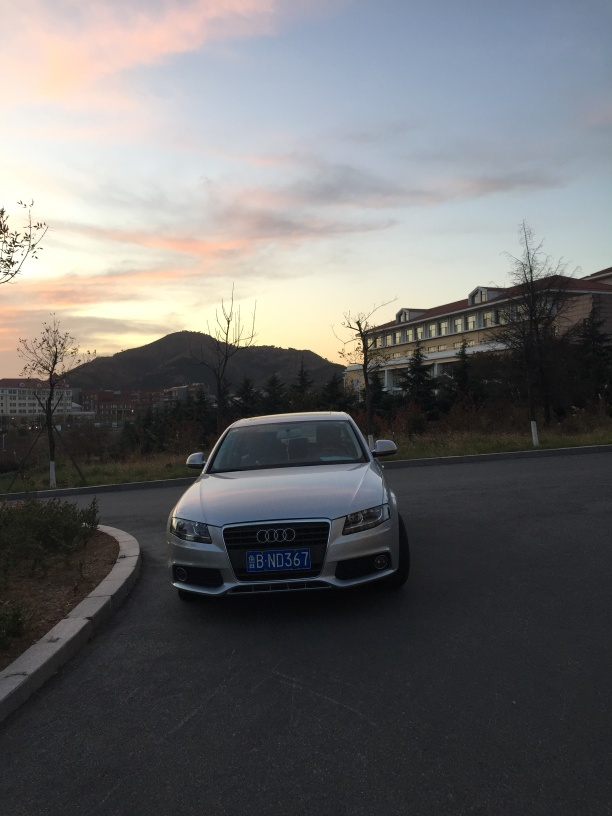Can you describe the setting of this image? The image captures a scene during twilight with a silver sedan parked on the side of a road. The sky is painted with hues of pink and blue from the setting sun, and a mountainous landscape provides a serene backdrop. There is a large building with multiple stories on the right, suggesting an urban or suburban environment. 